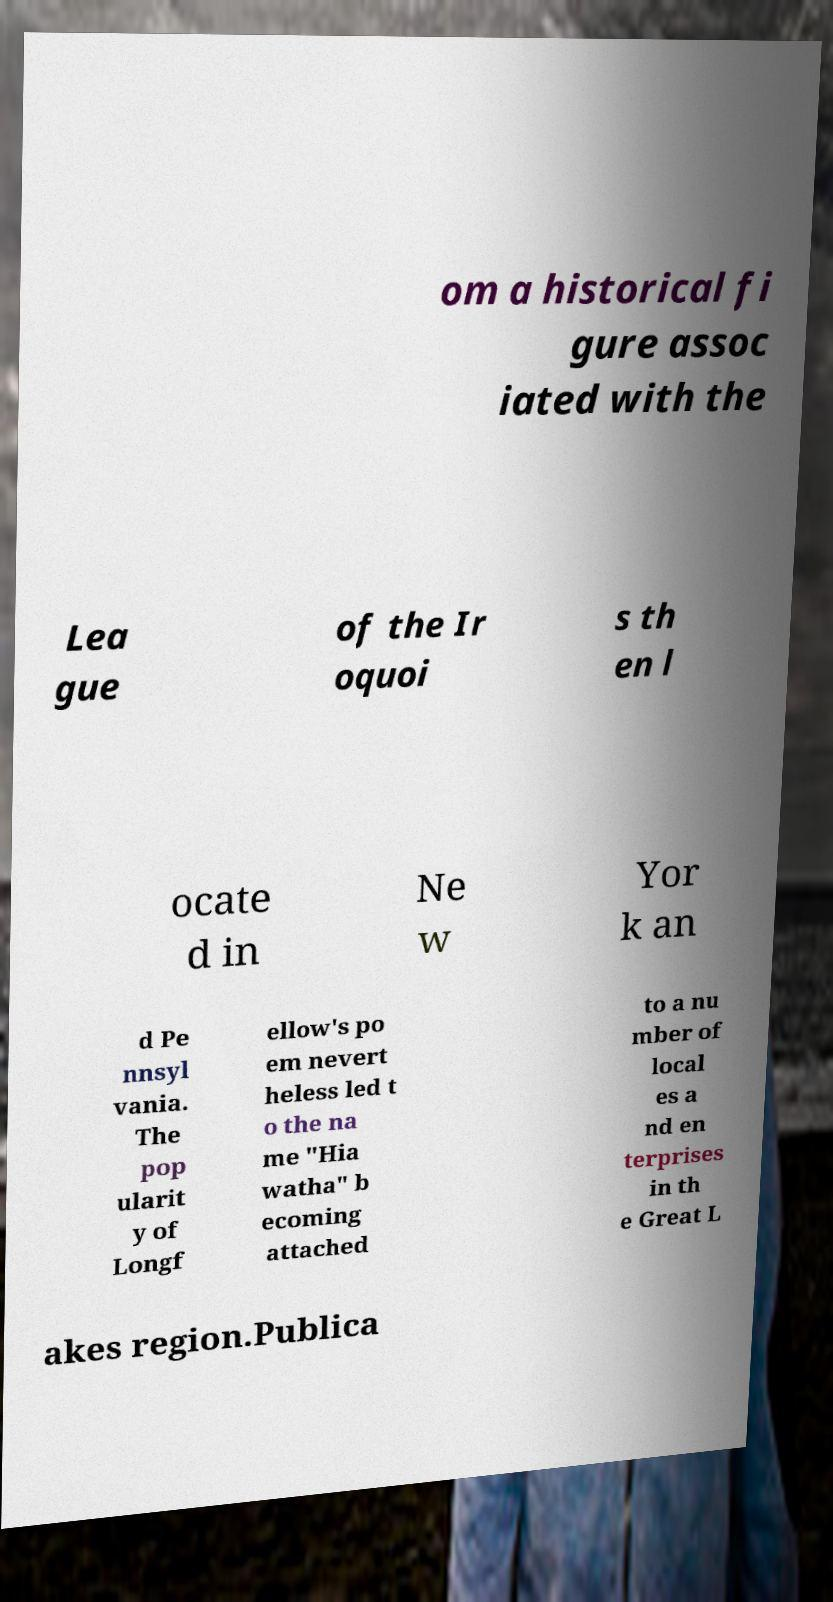Could you assist in decoding the text presented in this image and type it out clearly? om a historical fi gure assoc iated with the Lea gue of the Ir oquoi s th en l ocate d in Ne w Yor k an d Pe nnsyl vania. The pop ularit y of Longf ellow's po em nevert heless led t o the na me "Hia watha" b ecoming attached to a nu mber of local es a nd en terprises in th e Great L akes region.Publica 